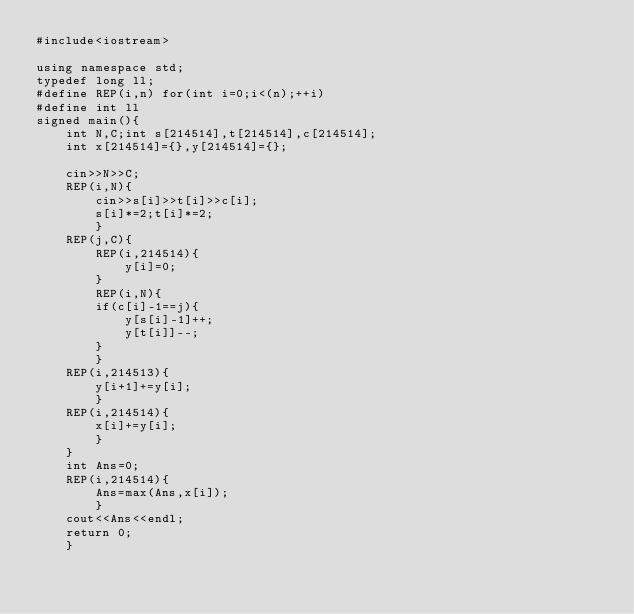<code> <loc_0><loc_0><loc_500><loc_500><_C++_>#include<iostream>

using namespace std;
typedef long ll;
#define REP(i,n) for(int i=0;i<(n);++i)
#define int ll
signed main(){
    int N,C;int s[214514],t[214514],c[214514];
    int x[214514]={},y[214514]={};
    
    cin>>N>>C;
    REP(i,N){
        cin>>s[i]>>t[i]>>c[i];
        s[i]*=2;t[i]*=2;
        }
    REP(j,C){
        REP(i,214514){
            y[i]=0;
        }
        REP(i,N){
        if(c[i]-1==j){    
            y[s[i]-1]++;
            y[t[i]]--;
        }
        }
    REP(i,214513){
        y[i+1]+=y[i];
        }
    REP(i,214514){
        x[i]+=y[i];    
        }
    }
    int Ans=0;
    REP(i,214514){
        Ans=max(Ans,x[i]);
        }
    cout<<Ans<<endl;
    return 0;
    }</code> 